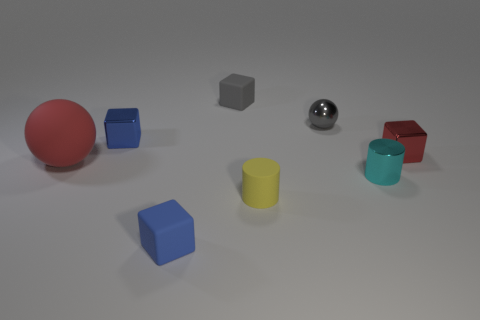How many metal things are either gray cubes or large purple cylinders?
Ensure brevity in your answer.  0. There is a tiny gray metal thing that is on the right side of the sphere to the left of the blue shiny cube; are there any small gray shiny spheres that are behind it?
Keep it short and to the point. No. There is a cylinder that is the same material as the gray block; what size is it?
Make the answer very short. Small. Are there any tiny cylinders in front of the tiny metallic cylinder?
Provide a succinct answer. Yes. There is a small matte block that is behind the cyan cylinder; are there any blue rubber cubes behind it?
Ensure brevity in your answer.  No. There is a red thing on the right side of the small metal sphere; is it the same size as the blue block in front of the red shiny object?
Your answer should be compact. Yes. What number of tiny things are red objects or gray matte things?
Offer a very short reply. 2. What is the blue object that is in front of the cylinder that is behind the tiny yellow cylinder made of?
Your answer should be very brief. Rubber. What is the shape of the rubber object that is the same color as the tiny sphere?
Offer a very short reply. Cube. Are there any tiny things made of the same material as the red block?
Your answer should be compact. Yes. 